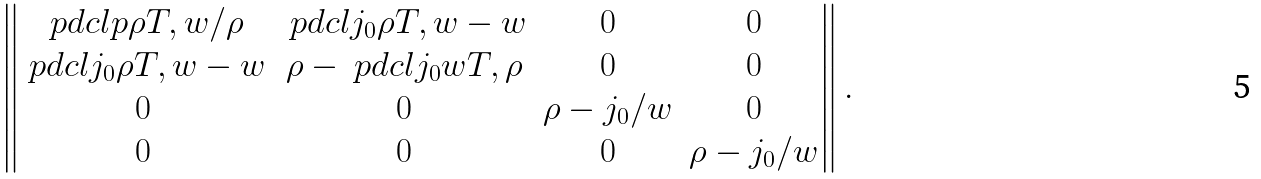<formula> <loc_0><loc_0><loc_500><loc_500>\begin{Vmatrix} \ p d c l { p } { \rho } { T , w } / \rho & \ p d c l { j _ { 0 } } { \rho } { T , w } - w & 0 & 0 \\ \ p d c l { j _ { 0 } } { \rho } { T , w } - w & \rho - \ p d c l { j _ { 0 } } { w } { T , \rho } & 0 & 0 \\ 0 & 0 & \rho - j _ { 0 } / w & 0 \\ 0 & 0 & 0 & \rho - j _ { 0 } / w \end{Vmatrix} .</formula> 